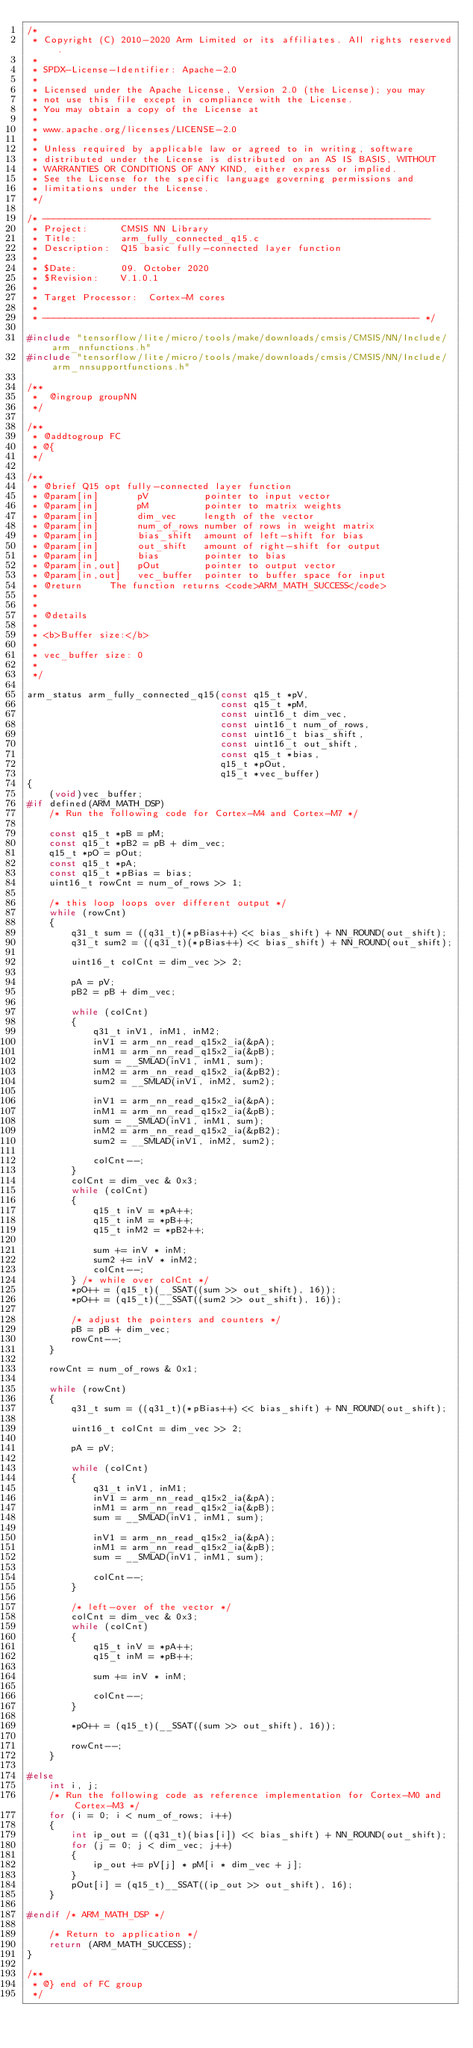Convert code to text. <code><loc_0><loc_0><loc_500><loc_500><_C_>/*
 * Copyright (C) 2010-2020 Arm Limited or its affiliates. All rights reserved.
 *
 * SPDX-License-Identifier: Apache-2.0
 *
 * Licensed under the Apache License, Version 2.0 (the License); you may
 * not use this file except in compliance with the License.
 * You may obtain a copy of the License at
 *
 * www.apache.org/licenses/LICENSE-2.0
 *
 * Unless required by applicable law or agreed to in writing, software
 * distributed under the License is distributed on an AS IS BASIS, WITHOUT
 * WARRANTIES OR CONDITIONS OF ANY KIND, either express or implied.
 * See the License for the specific language governing permissions and
 * limitations under the License.
 */

/* ----------------------------------------------------------------------
 * Project:      CMSIS NN Library
 * Title:        arm_fully_connected_q15.c
 * Description:  Q15 basic fully-connected layer function
 *
 * $Date:        09. October 2020
 * $Revision:    V.1.0.1
 *
 * Target Processor:  Cortex-M cores
 *
 * -------------------------------------------------------------------- */

#include "tensorflow/lite/micro/tools/make/downloads/cmsis/CMSIS/NN/Include/arm_nnfunctions.h"
#include "tensorflow/lite/micro/tools/make/downloads/cmsis/CMSIS/NN/Include/arm_nnsupportfunctions.h"

/**
 *  @ingroup groupNN
 */

/**
 * @addtogroup FC
 * @{
 */

/**
 * @brief Q15 opt fully-connected layer function
 * @param[in]       pV          pointer to input vector
 * @param[in]       pM          pointer to matrix weights
 * @param[in]       dim_vec     length of the vector
 * @param[in]       num_of_rows number of rows in weight matrix
 * @param[in]       bias_shift  amount of left-shift for bias
 * @param[in]       out_shift   amount of right-shift for output
 * @param[in]       bias        pointer to bias
 * @param[in,out]   pOut        pointer to output vector
 * @param[in,out]   vec_buffer  pointer to buffer space for input
 * @return     The function returns <code>ARM_MATH_SUCCESS</code>
 *
 *
 * @details
 *
 * <b>Buffer size:</b>
 *
 * vec_buffer size: 0
 *
 */

arm_status arm_fully_connected_q15(const q15_t *pV,
                                   const q15_t *pM,
                                   const uint16_t dim_vec,
                                   const uint16_t num_of_rows,
                                   const uint16_t bias_shift,
                                   const uint16_t out_shift,
                                   const q15_t *bias,
                                   q15_t *pOut,
                                   q15_t *vec_buffer)
{
    (void)vec_buffer;
#if defined(ARM_MATH_DSP)
    /* Run the following code for Cortex-M4 and Cortex-M7 */

    const q15_t *pB = pM;
    const q15_t *pB2 = pB + dim_vec;
    q15_t *pO = pOut;
    const q15_t *pA;
    const q15_t *pBias = bias;
    uint16_t rowCnt = num_of_rows >> 1;

    /* this loop loops over different output */
    while (rowCnt)
    {
        q31_t sum = ((q31_t)(*pBias++) << bias_shift) + NN_ROUND(out_shift);
        q31_t sum2 = ((q31_t)(*pBias++) << bias_shift) + NN_ROUND(out_shift);

        uint16_t colCnt = dim_vec >> 2;

        pA = pV;
        pB2 = pB + dim_vec;

        while (colCnt)
        {
            q31_t inV1, inM1, inM2;
            inV1 = arm_nn_read_q15x2_ia(&pA);
            inM1 = arm_nn_read_q15x2_ia(&pB);
            sum = __SMLAD(inV1, inM1, sum);
            inM2 = arm_nn_read_q15x2_ia(&pB2);
            sum2 = __SMLAD(inV1, inM2, sum2);

            inV1 = arm_nn_read_q15x2_ia(&pA);
            inM1 = arm_nn_read_q15x2_ia(&pB);
            sum = __SMLAD(inV1, inM1, sum);
            inM2 = arm_nn_read_q15x2_ia(&pB2);
            sum2 = __SMLAD(inV1, inM2, sum2);

            colCnt--;
        }
        colCnt = dim_vec & 0x3;
        while (colCnt)
        {
            q15_t inV = *pA++;
            q15_t inM = *pB++;
            q15_t inM2 = *pB2++;

            sum += inV * inM;
            sum2 += inV * inM2;
            colCnt--;
        } /* while over colCnt */
        *pO++ = (q15_t)(__SSAT((sum >> out_shift), 16));
        *pO++ = (q15_t)(__SSAT((sum2 >> out_shift), 16));

        /* adjust the pointers and counters */
        pB = pB + dim_vec;
        rowCnt--;
    }

    rowCnt = num_of_rows & 0x1;

    while (rowCnt)
    {
        q31_t sum = ((q31_t)(*pBias++) << bias_shift) + NN_ROUND(out_shift);

        uint16_t colCnt = dim_vec >> 2;

        pA = pV;

        while (colCnt)
        {
            q31_t inV1, inM1;
            inV1 = arm_nn_read_q15x2_ia(&pA);
            inM1 = arm_nn_read_q15x2_ia(&pB);
            sum = __SMLAD(inV1, inM1, sum);

            inV1 = arm_nn_read_q15x2_ia(&pA);
            inM1 = arm_nn_read_q15x2_ia(&pB);
            sum = __SMLAD(inV1, inM1, sum);

            colCnt--;
        }

        /* left-over of the vector */
        colCnt = dim_vec & 0x3;
        while (colCnt)
        {
            q15_t inV = *pA++;
            q15_t inM = *pB++;

            sum += inV * inM;

            colCnt--;
        }

        *pO++ = (q15_t)(__SSAT((sum >> out_shift), 16));

        rowCnt--;
    }

#else
    int i, j;
    /* Run the following code as reference implementation for Cortex-M0 and Cortex-M3 */
    for (i = 0; i < num_of_rows; i++)
    {
        int ip_out = ((q31_t)(bias[i]) << bias_shift) + NN_ROUND(out_shift);
        for (j = 0; j < dim_vec; j++)
        {
            ip_out += pV[j] * pM[i * dim_vec + j];
        }
        pOut[i] = (q15_t)__SSAT((ip_out >> out_shift), 16);
    }

#endif /* ARM_MATH_DSP */

    /* Return to application */
    return (ARM_MATH_SUCCESS);
}

/**
 * @} end of FC group
 */
</code> 